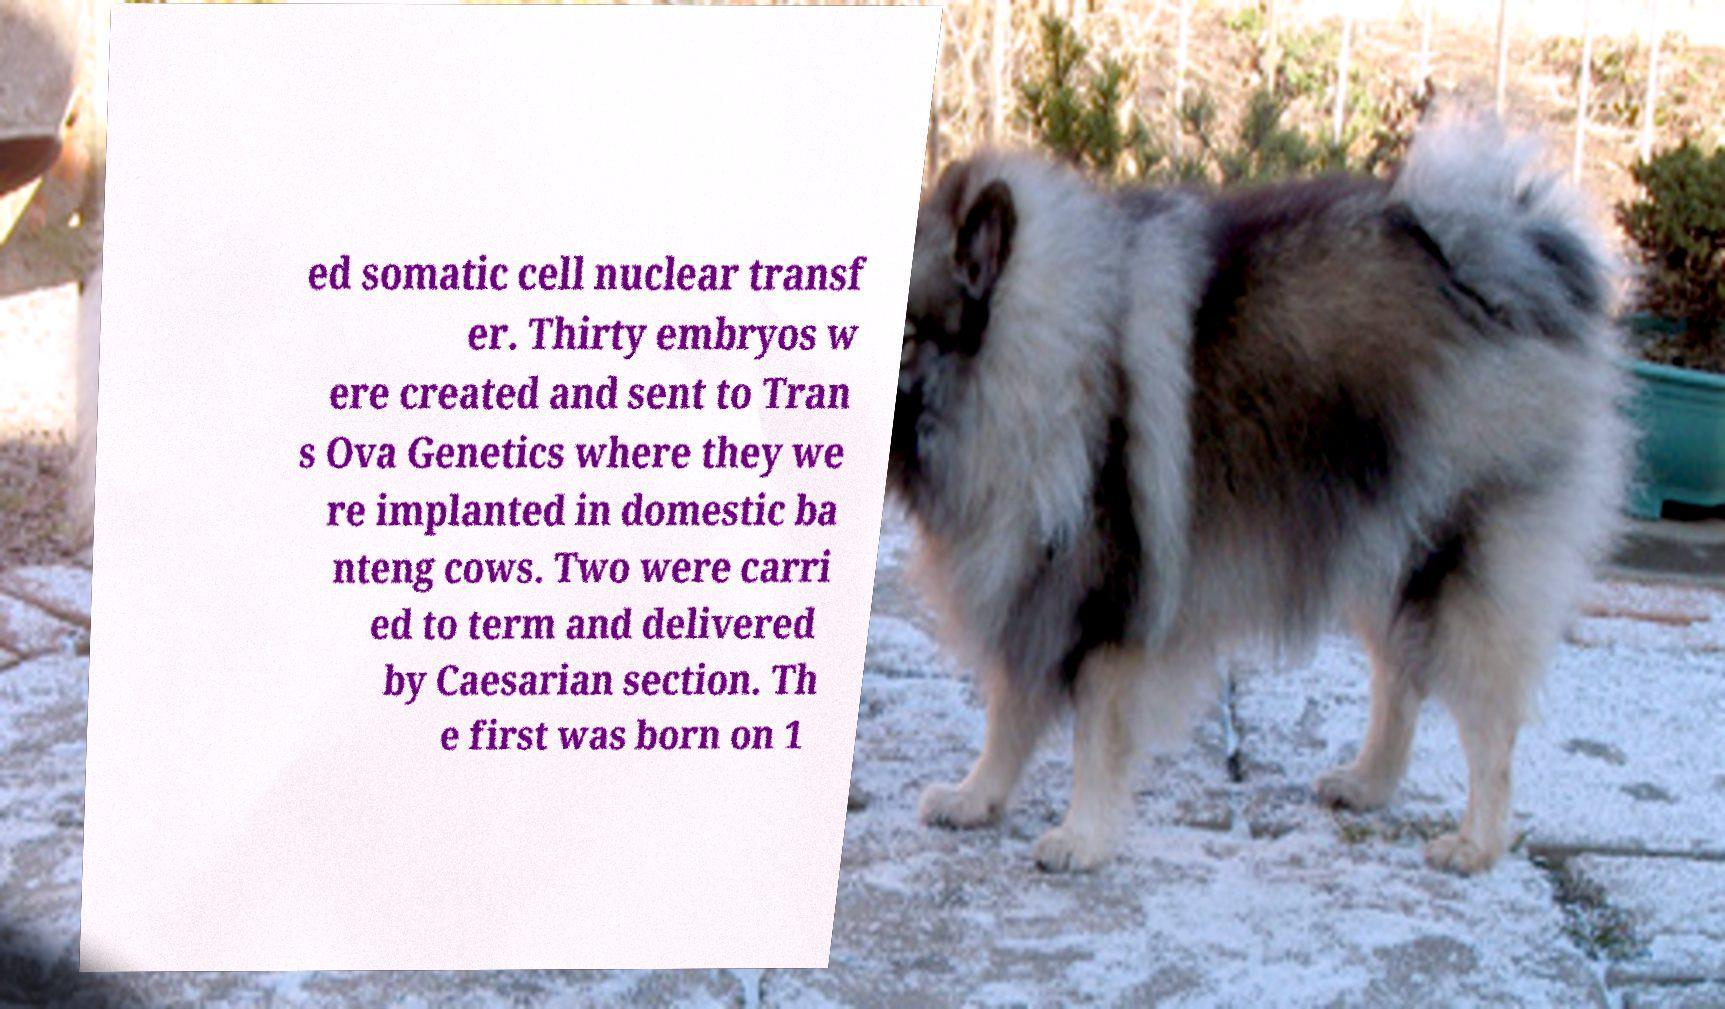Could you extract and type out the text from this image? ed somatic cell nuclear transf er. Thirty embryos w ere created and sent to Tran s Ova Genetics where they we re implanted in domestic ba nteng cows. Two were carri ed to term and delivered by Caesarian section. Th e first was born on 1 